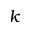Convert formula to latex. <formula><loc_0><loc_0><loc_500><loc_500>k</formula> 